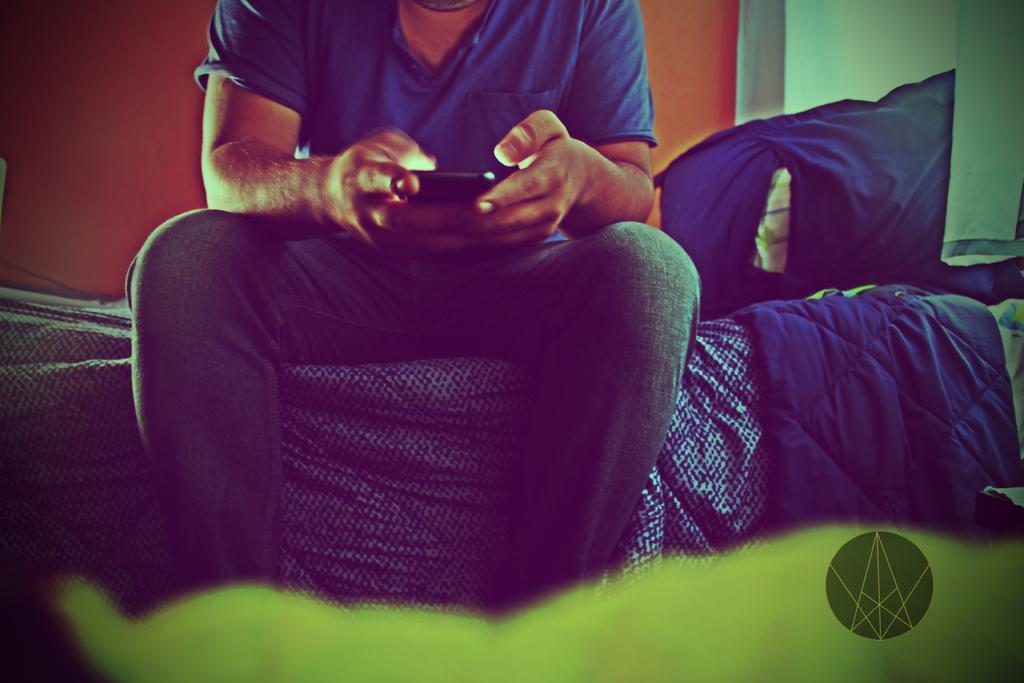Can you describe this image briefly? In this picture we can see a person sitting,holding a mobile and in the background we can see a wall. 